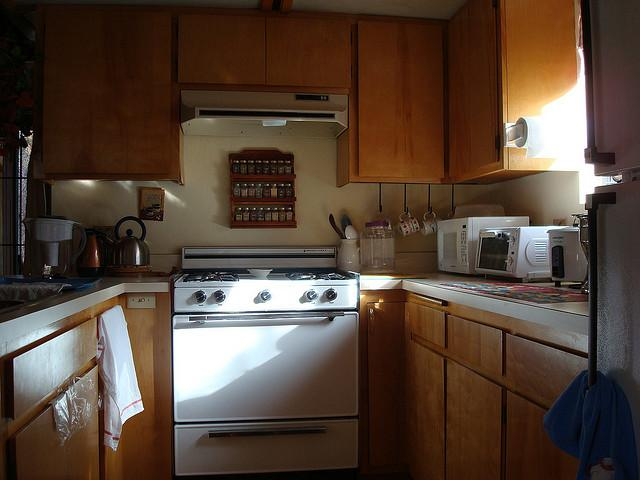What would someone use the objects above the stove for?

Choices:
A) teaching
B) drinking
C) seasoning
D) cleaning seasoning 